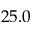<formula> <loc_0><loc_0><loc_500><loc_500>2 5 . 0</formula> 